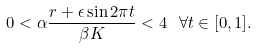Convert formula to latex. <formula><loc_0><loc_0><loc_500><loc_500>0 < \alpha \frac { r + \epsilon \sin 2 \pi t } { \beta K } < 4 \, \ \forall t \in [ 0 , 1 ] .</formula> 